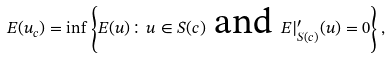Convert formula to latex. <formula><loc_0><loc_0><loc_500><loc_500>E ( u _ { c } ) = \inf \left \{ E ( u ) \colon u \in S ( c ) \text { and } E | _ { S ( c ) } ^ { \prime } ( u ) = 0 \right \} ,</formula> 